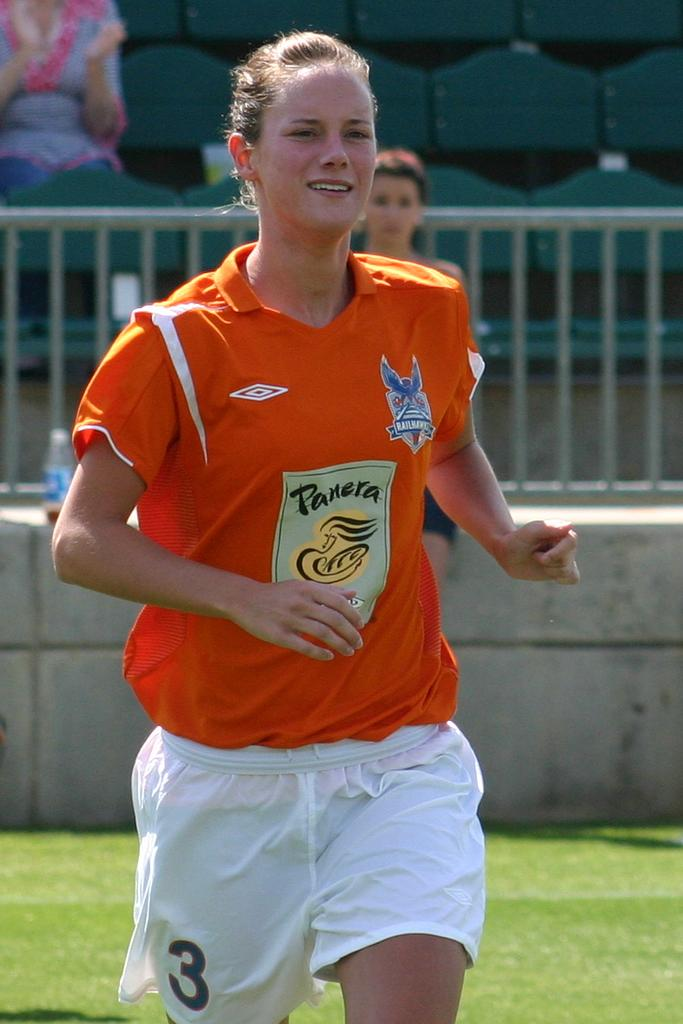Provide a one-sentence caption for the provided image. A soccer player wears an orange jersey that is sponsored by Panera. 